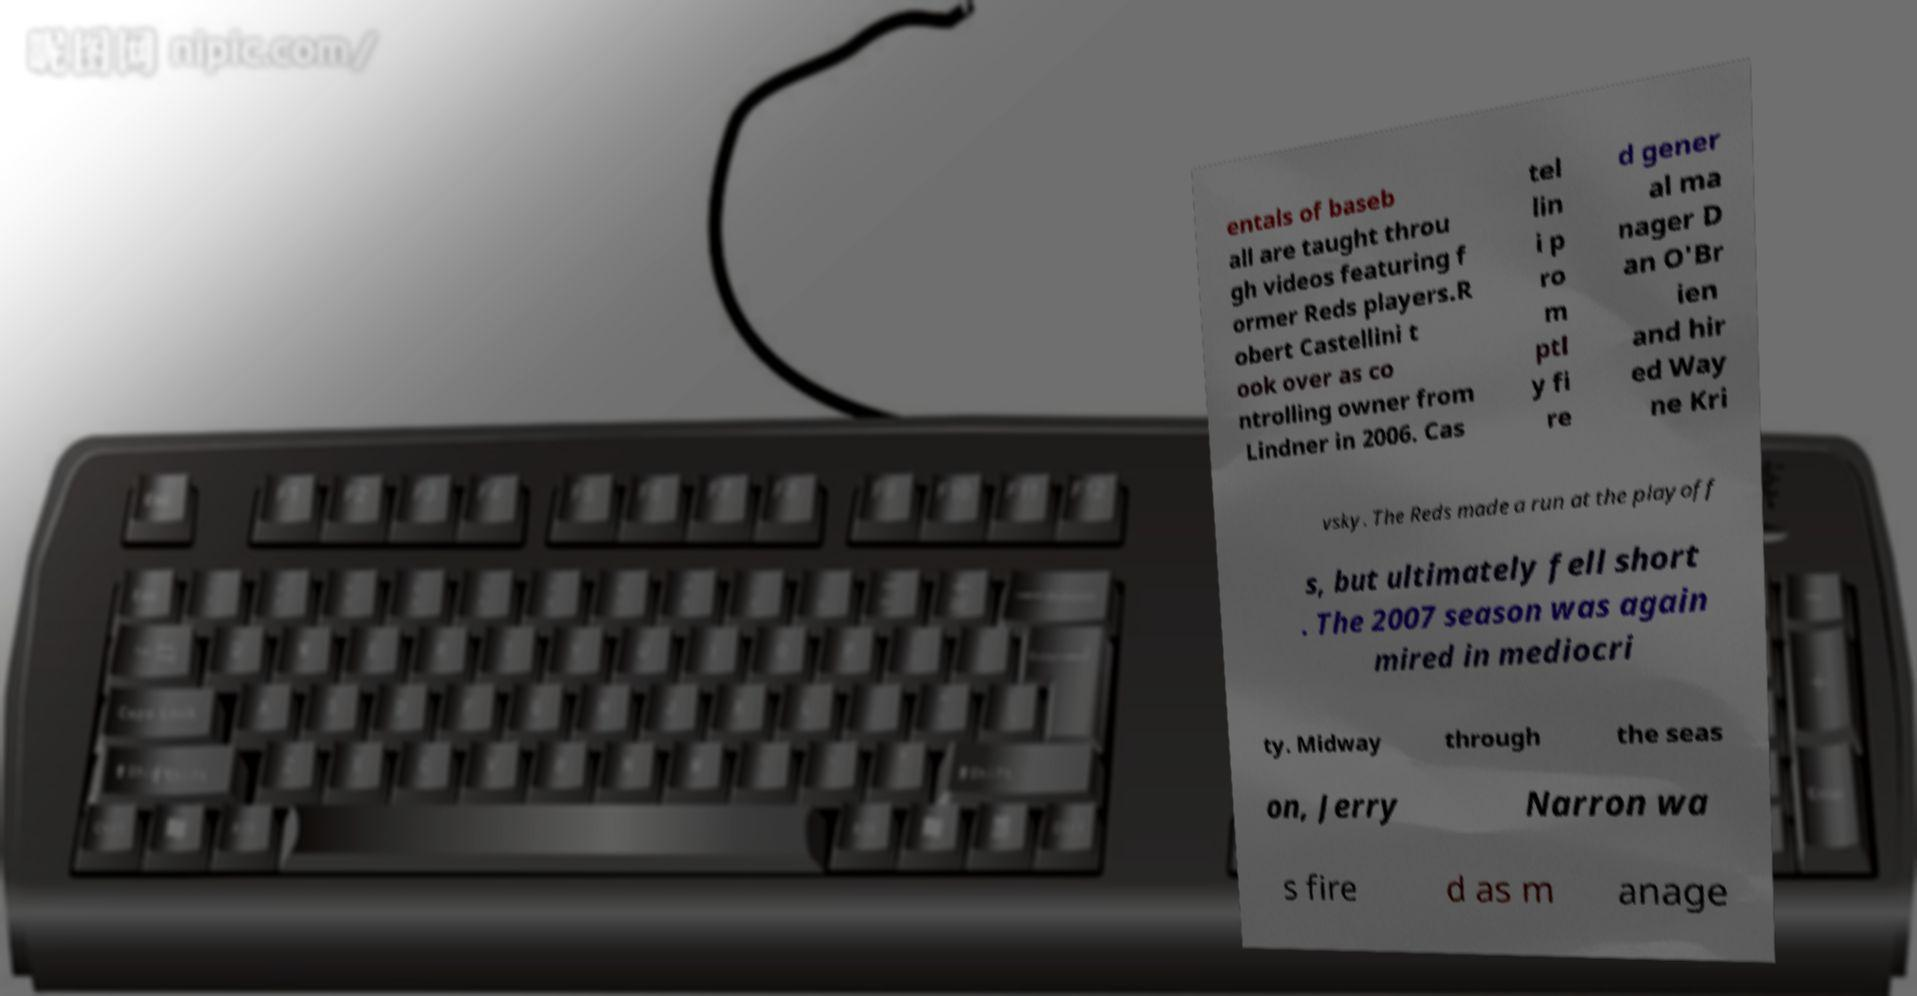I need the written content from this picture converted into text. Can you do that? entals of baseb all are taught throu gh videos featuring f ormer Reds players.R obert Castellini t ook over as co ntrolling owner from Lindner in 2006. Cas tel lin i p ro m ptl y fi re d gener al ma nager D an O'Br ien and hir ed Way ne Kri vsky. The Reds made a run at the playoff s, but ultimately fell short . The 2007 season was again mired in mediocri ty. Midway through the seas on, Jerry Narron wa s fire d as m anage 